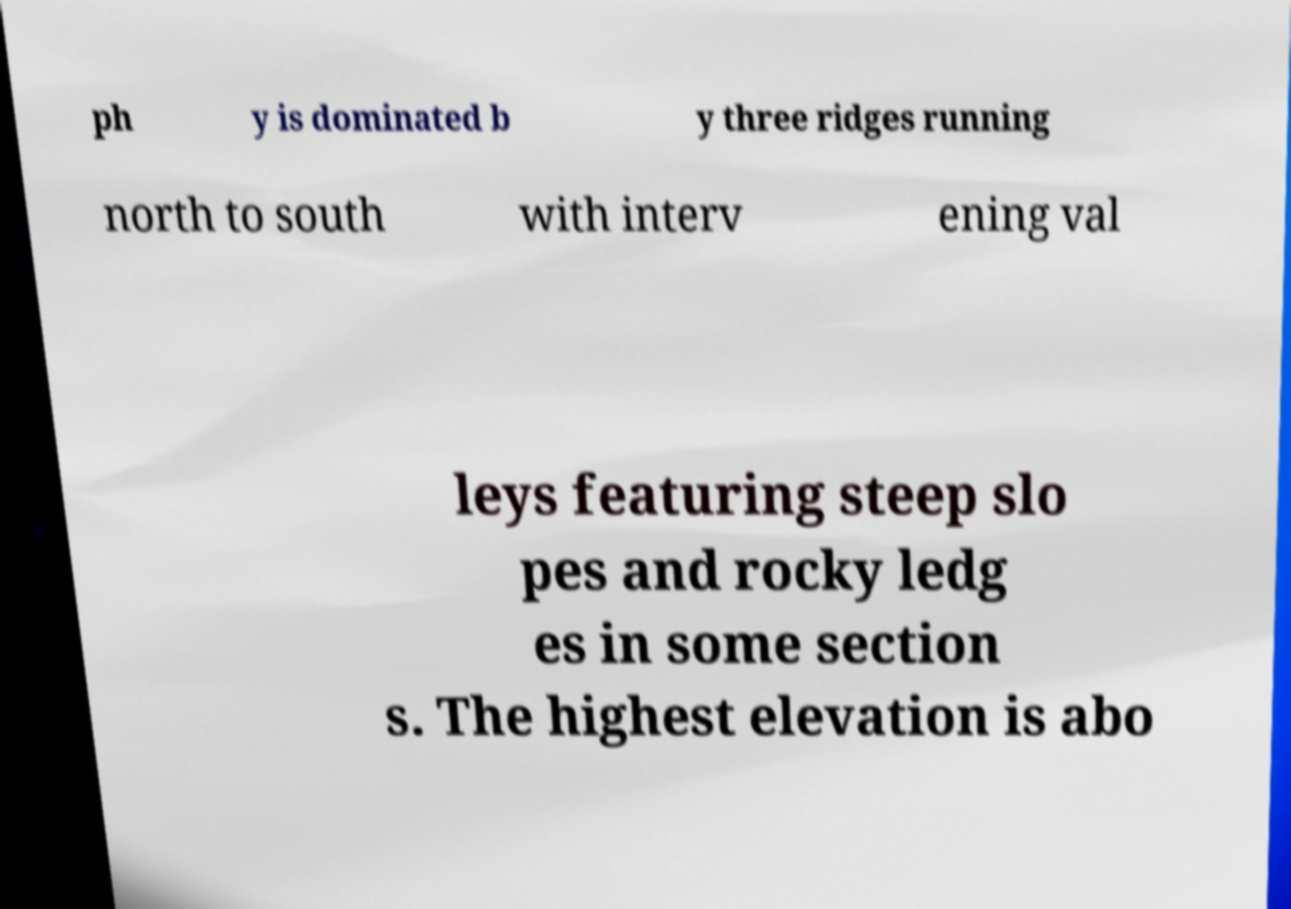Please read and relay the text visible in this image. What does it say? ph y is dominated b y three ridges running north to south with interv ening val leys featuring steep slo pes and rocky ledg es in some section s. The highest elevation is abo 